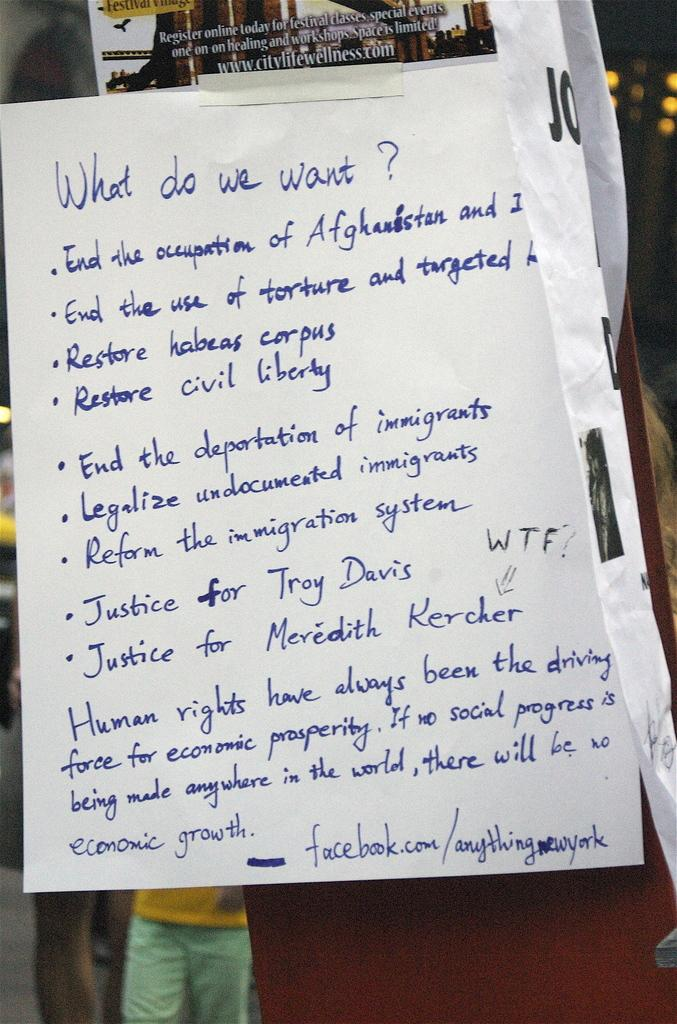What is the main object in the image with text on it? There is a paper with text written on it in the image. Can you describe the background of the image? There is a person in the background of the image. What color is one of the objects in the image? There is an object that is brown in color in the image. How many cows are grazing on the grass in the image? There are no cows or grass present in the image. What type of rings can be seen on the person's fingers in the image? There is no person with rings visible in the image. 